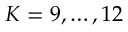Convert formula to latex. <formula><loc_0><loc_0><loc_500><loc_500>K = 9 , \dots , 1 2</formula> 